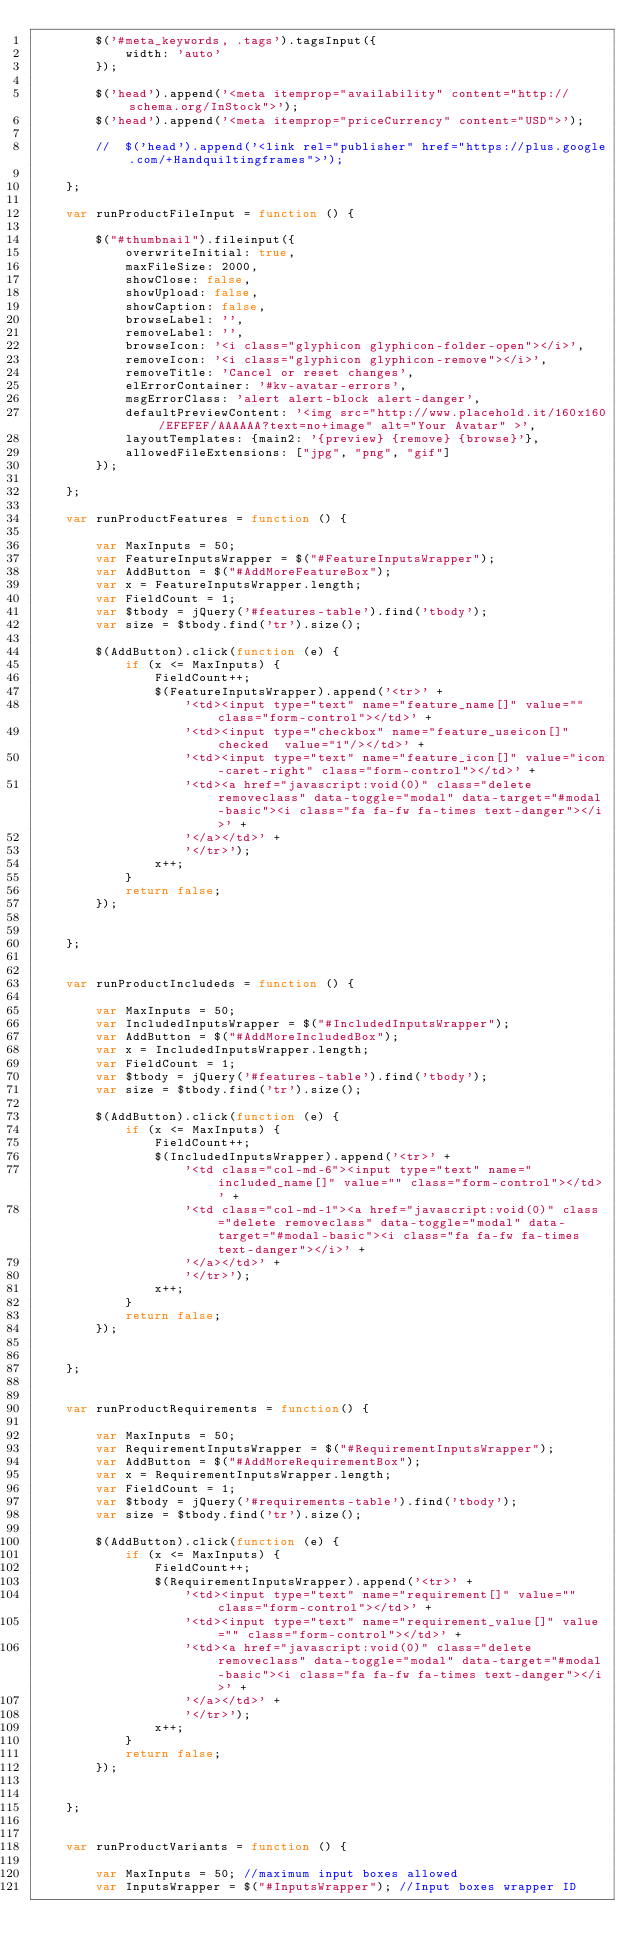<code> <loc_0><loc_0><loc_500><loc_500><_JavaScript_>        $('#meta_keywords, .tags').tagsInput({
            width: 'auto'
        });

        $('head').append('<meta itemprop="availability" content="http://schema.org/InStock">');
        $('head').append('<meta itemprop="priceCurrency" content="USD">');

        //  $('head').append('<link rel="publisher" href="https://plus.google.com/+Handquiltingframes">');

    };

    var runProductFileInput = function () {

        $("#thumbnail").fileinput({
            overwriteInitial: true,
            maxFileSize: 2000,
            showClose: false,
            showUpload: false,
            showCaption: false,
            browseLabel: '',
            removeLabel: '',
            browseIcon: '<i class="glyphicon glyphicon-folder-open"></i>',
            removeIcon: '<i class="glyphicon glyphicon-remove"></i>',
            removeTitle: 'Cancel or reset changes',
            elErrorContainer: '#kv-avatar-errors',
            msgErrorClass: 'alert alert-block alert-danger',
            defaultPreviewContent: '<img src="http://www.placehold.it/160x160/EFEFEF/AAAAAA?text=no+image" alt="Your Avatar" >',
            layoutTemplates: {main2: '{preview} {remove} {browse}'},
            allowedFileExtensions: ["jpg", "png", "gif"]
        });

    };

    var runProductFeatures = function () {

        var MaxInputs = 50;
        var FeatureInputsWrapper = $("#FeatureInputsWrapper");
        var AddButton = $("#AddMoreFeatureBox");
        var x = FeatureInputsWrapper.length;
        var FieldCount = 1;
        var $tbody = jQuery('#features-table').find('tbody');
        var size = $tbody.find('tr').size();

        $(AddButton).click(function (e) {
            if (x <= MaxInputs) {
                FieldCount++;
                $(FeatureInputsWrapper).append('<tr>' +
                    '<td><input type="text" name="feature_name[]" value="" class="form-control"></td>' +
                    '<td><input type="checkbox" name="feature_useicon[]" checked  value="1"/></td>' +
                    '<td><input type="text" name="feature_icon[]" value="icon-caret-right" class="form-control"></td>' +
                    '<td><a href="javascript:void(0)" class="delete removeclass" data-toggle="modal" data-target="#modal-basic"><i class="fa fa-fw fa-times text-danger"></i>' +
                    '</a></td>' +
                    '</tr>');
                x++;
            }
            return false;
        });


    };


    var runProductIncludeds = function () {

        var MaxInputs = 50;
        var IncludedInputsWrapper = $("#IncludedInputsWrapper");
        var AddButton = $("#AddMoreIncludedBox");
        var x = IncludedInputsWrapper.length;
        var FieldCount = 1;
        var $tbody = jQuery('#features-table').find('tbody');
        var size = $tbody.find('tr').size();

        $(AddButton).click(function (e) {
            if (x <= MaxInputs) {
                FieldCount++;
                $(IncludedInputsWrapper).append('<tr>' +
                    '<td class="col-md-6"><input type="text" name="included_name[]" value="" class="form-control"></td>' +
                    '<td class="col-md-1"><a href="javascript:void(0)" class="delete removeclass" data-toggle="modal" data-target="#modal-basic"><i class="fa fa-fw fa-times text-danger"></i>' +
                    '</a></td>' +
                    '</tr>');
                x++;
            }
            return false;
        });


    };


    var runProductRequirements = function() {

        var MaxInputs = 50;
        var RequirementInputsWrapper = $("#RequirementInputsWrapper");
        var AddButton = $("#AddMoreRequirementBox");
        var x = RequirementInputsWrapper.length;
        var FieldCount = 1;
        var $tbody = jQuery('#requirements-table').find('tbody');
        var size = $tbody.find('tr').size();

        $(AddButton).click(function (e) {
            if (x <= MaxInputs) {
                FieldCount++;
                $(RequirementInputsWrapper).append('<tr>' +
                    '<td><input type="text" name="requirement[]" value="" class="form-control"></td>' +
                    '<td><input type="text" name="requirement_value[]" value="" class="form-control"></td>' +
                    '<td><a href="javascript:void(0)" class="delete removeclass" data-toggle="modal" data-target="#modal-basic"><i class="fa fa-fw fa-times text-danger"></i>' +
                    '</a></td>' +
                    '</tr>');
                x++;
            }
            return false;
        });


    };


    var runProductVariants = function () {

        var MaxInputs = 50; //maximum input boxes allowed
        var InputsWrapper = $("#InputsWrapper"); //Input boxes wrapper ID</code> 